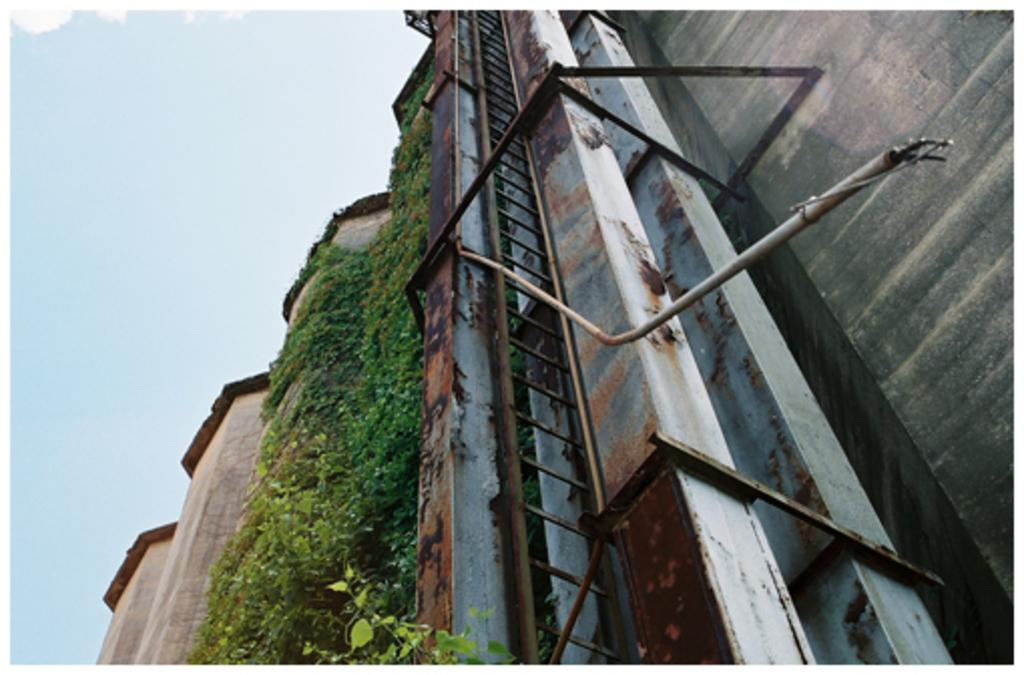What type of structure is shown in the image? There is a building wall in the image. What is growing on the building wall? Creepers are present on the building wall. What else can be seen on the building wall? Rusted rods are visible on the building wall. What is located at the bottom of the image? There is a plant at the bottom of the image. What can be seen in the background of the image? The sky is visible in the image. How many times does the grandfather spark the fire in the image? There is no grandfather or fire present in the image. What type of number is written on the building wall in the image? There are no numbers written on the building wall in the image. 